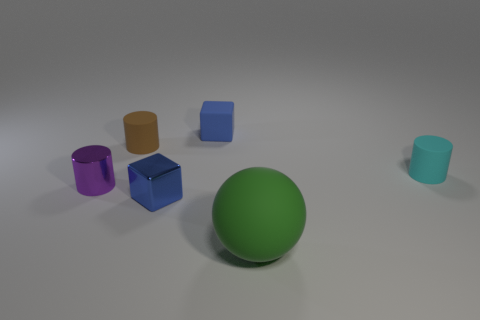Are there any metallic things that are behind the matte cylinder to the left of the matte cylinder on the right side of the large matte ball?
Provide a short and direct response. No. What is the color of the big sphere?
Give a very brief answer. Green. What is the color of the metal cylinder that is the same size as the cyan rubber object?
Provide a short and direct response. Purple. There is a metal thing that is right of the small brown rubber cylinder; is its shape the same as the cyan object?
Your response must be concise. No. The small block that is behind the small blue object that is in front of the cylinder that is on the right side of the tiny rubber cube is what color?
Provide a succinct answer. Blue. Are any large green matte balls visible?
Your answer should be very brief. Yes. How many other objects are there of the same size as the shiny cylinder?
Provide a succinct answer. 4. Does the rubber block have the same color as the block that is in front of the purple thing?
Give a very brief answer. Yes. How many things are either tiny purple metal cylinders or tiny blocks?
Make the answer very short. 3. Are there any other things that are the same color as the metallic cylinder?
Keep it short and to the point. No. 